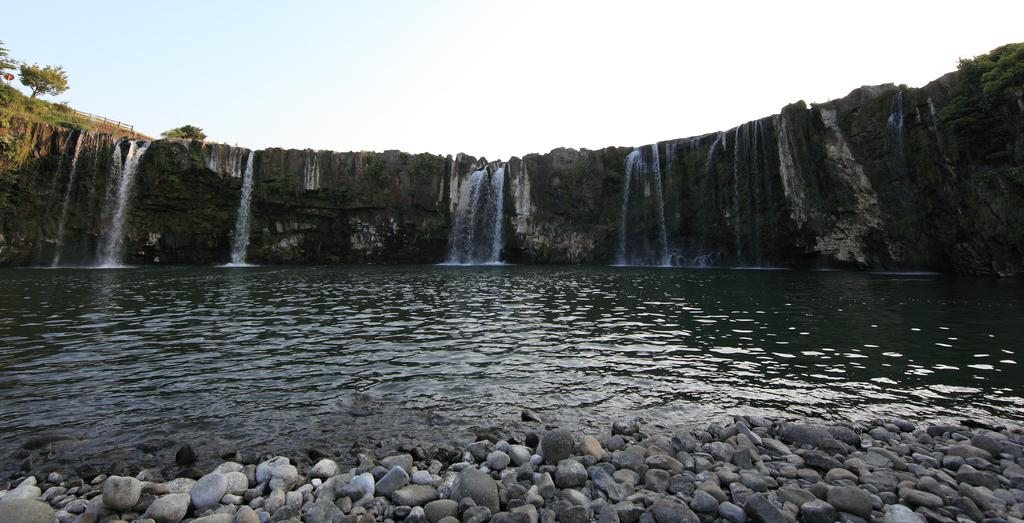What type of natural elements can be seen in the image? There are stones, water, and trees visible in the image. What specific feature of water is present in the image? There is a waterfall in the image. What type of barrier is present in the image? There is a fence in the image. What can be seen in the background of the image? The sky is visible in the background of the image, and it is plain. Can you tell me how many friends are present in the image? There are no friends present in the image; it features natural elements such as stones, water, and trees. What type of coast can be seen in the image? There is no coast present in the image; it features a waterfall and other natural elements. 